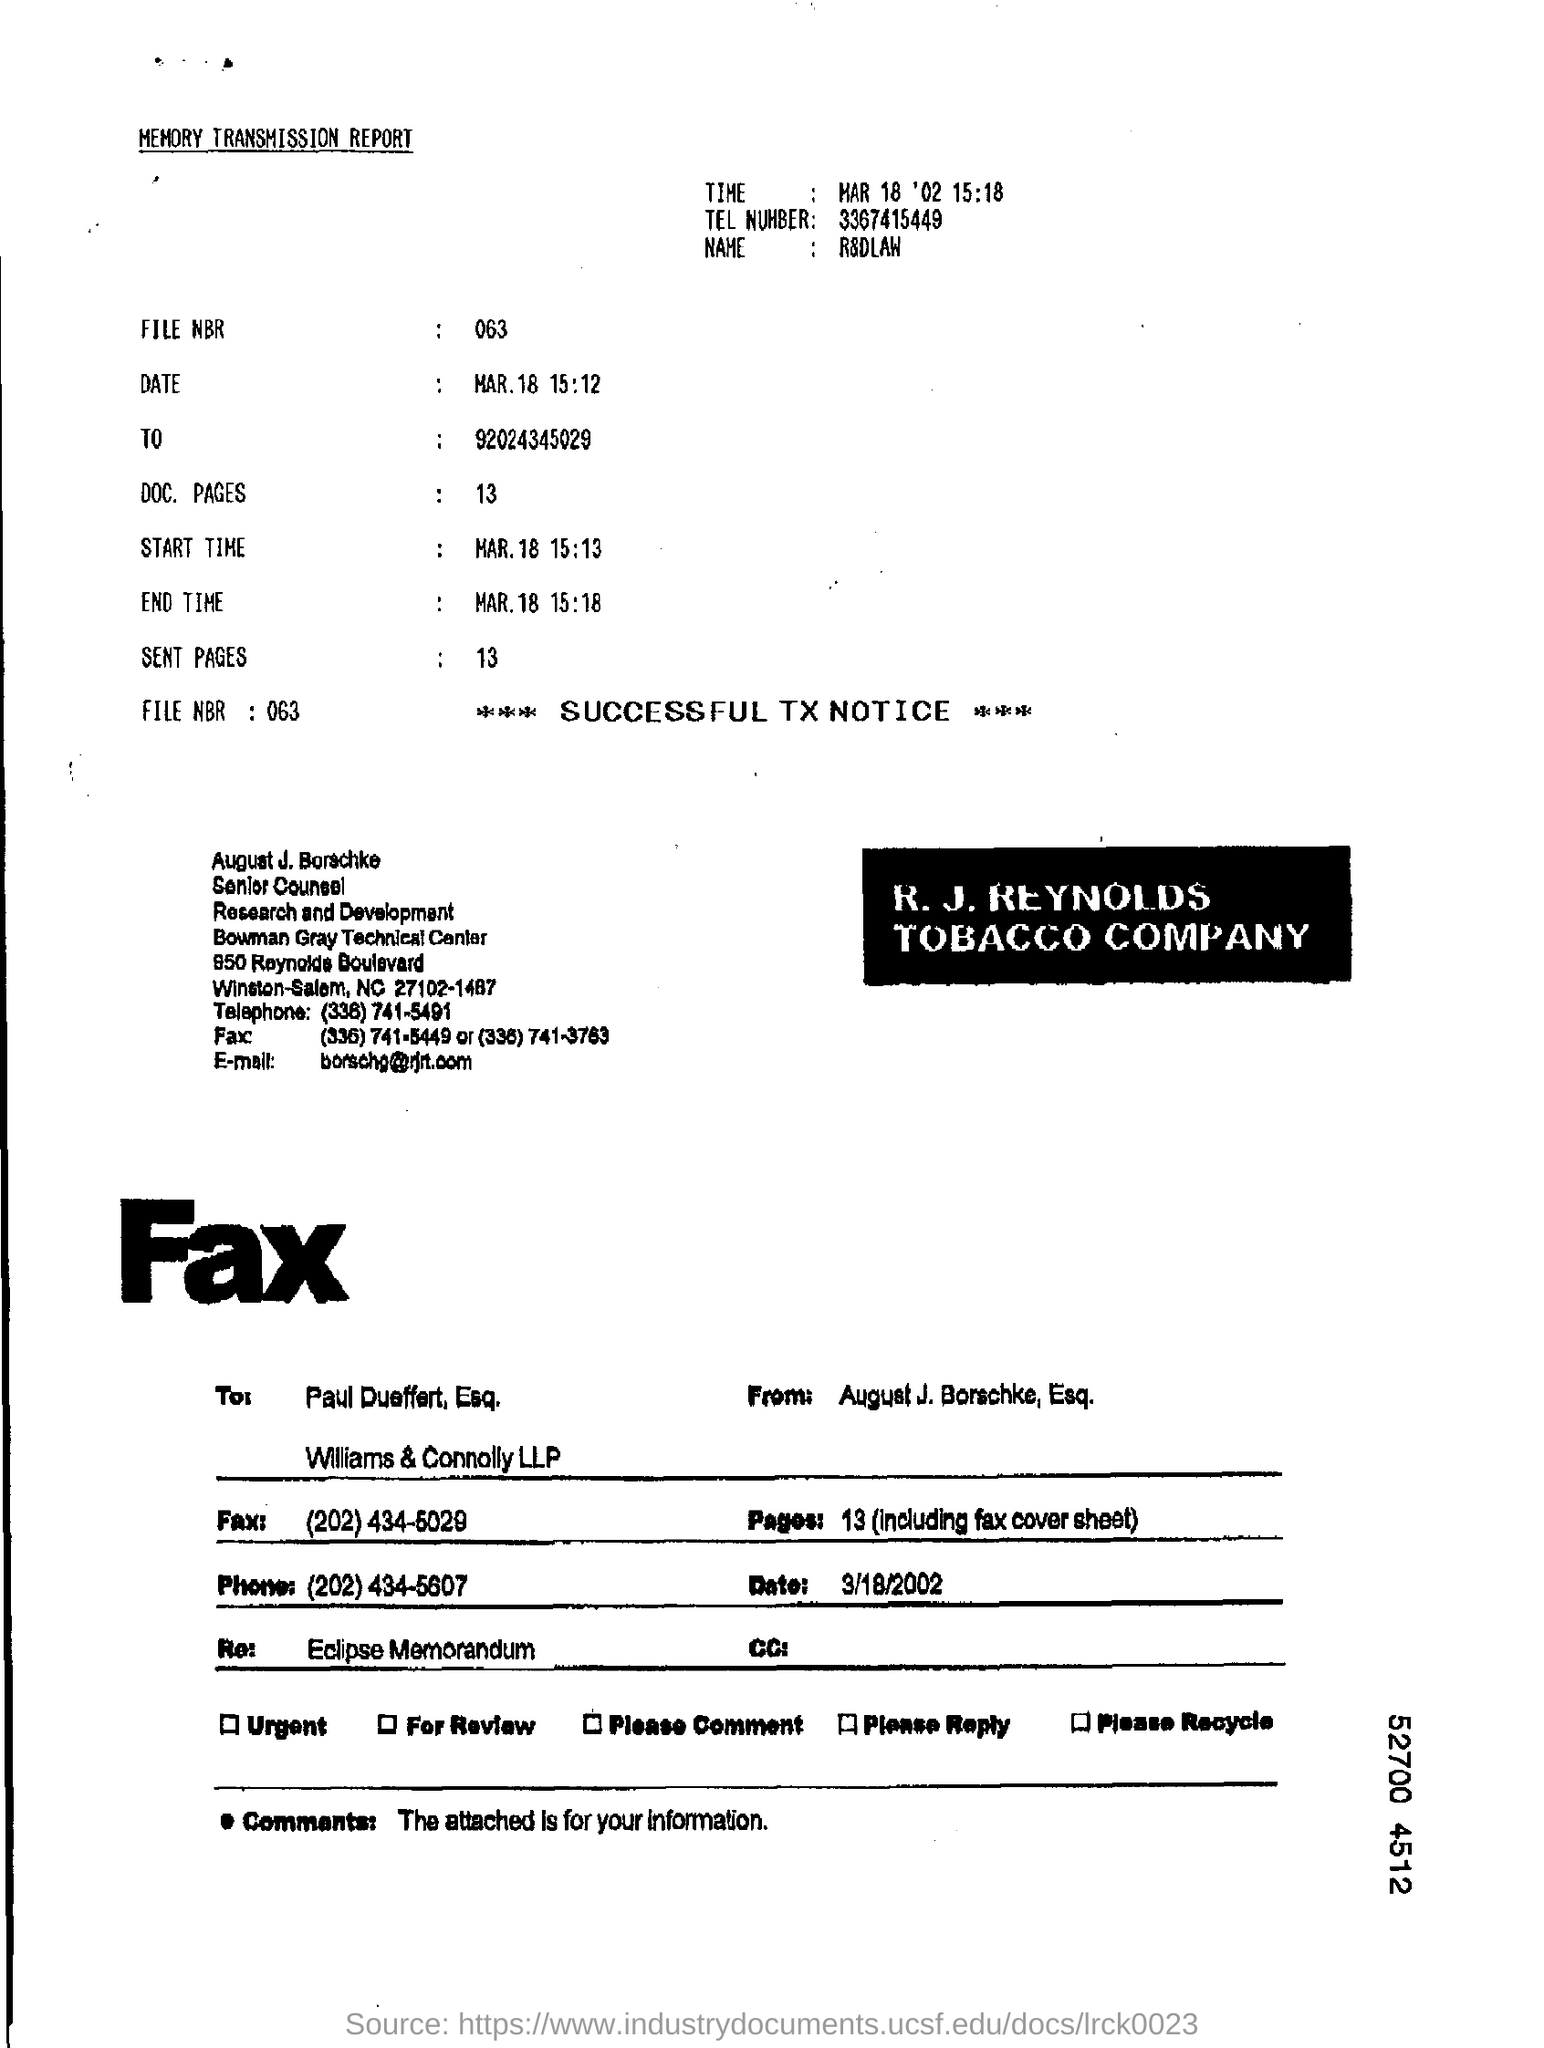What is the File NBR?
Provide a short and direct response. 063. Who is this Fax from?
Your answer should be very brief. August J. Borschke, Esq. 